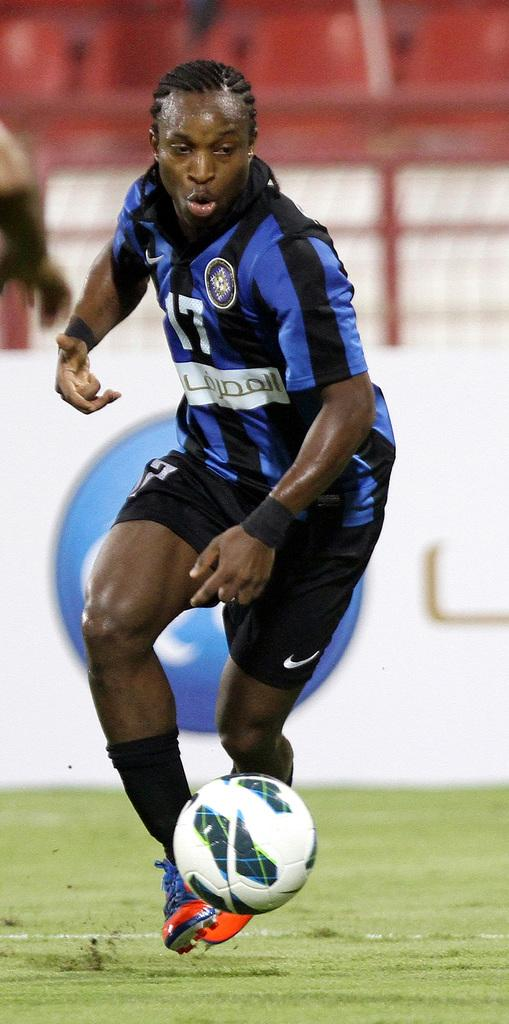Who is in the image? There is a person in the image. What is the person wearing? The person is wearing a blue and a black dress. What activity is the person engaged in? The person is playing football. What object is associated with the game of football in the image? A football is present in the image. What is the setting of the image? The image shows a green lawn. Are the person's friends holding an ornament in the image? There is no mention of friends or an ornament in the image; it only shows a person playing football on a green lawn. 